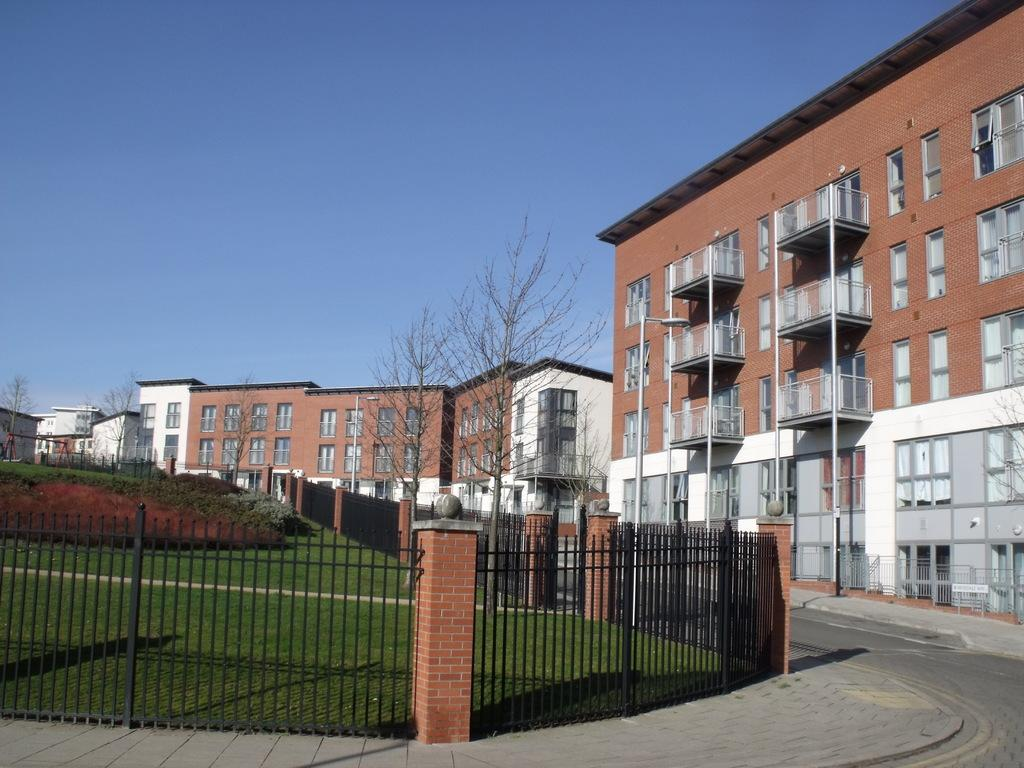What is located in the center of the image? There are buildings in the center of the image. What separates different areas in the image? There is a boundary in the image. What type of vegetation can be seen on the left side of the image? There is grass land on the left side of the image. What type of advice can be seen written on the grass in the image? There is no advice written on the grass in the image; it is a field of grass. Can you tell me how much honey is being produced by the buildings in the image? There is no mention of honey production in the image; it features buildings and grass land. 